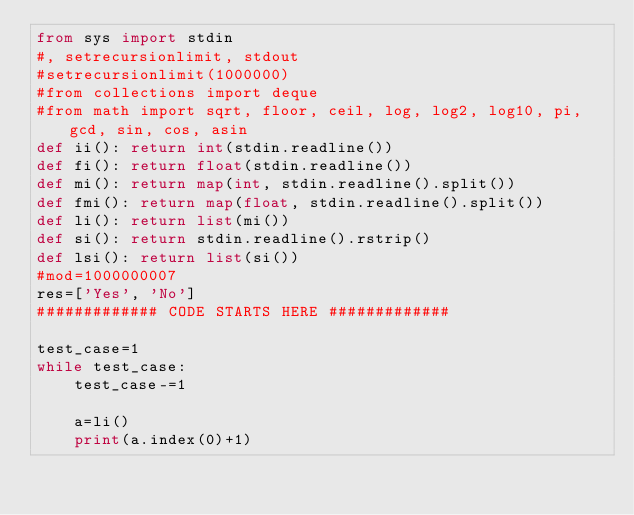Convert code to text. <code><loc_0><loc_0><loc_500><loc_500><_Python_>from sys import stdin
#, setrecursionlimit, stdout
#setrecursionlimit(1000000)
#from collections import deque
#from math import sqrt, floor, ceil, log, log2, log10, pi, gcd, sin, cos, asin
def ii(): return int(stdin.readline())
def fi(): return float(stdin.readline())
def mi(): return map(int, stdin.readline().split())
def fmi(): return map(float, stdin.readline().split())
def li(): return list(mi())
def si(): return stdin.readline().rstrip()
def lsi(): return list(si())
#mod=1000000007
res=['Yes', 'No']
############# CODE STARTS HERE #############

test_case=1
while test_case:
    test_case-=1

    a=li()
    print(a.index(0)+1)</code> 